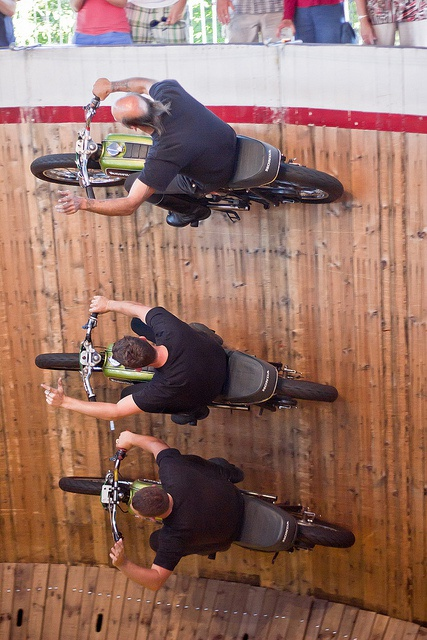Describe the objects in this image and their specific colors. I can see people in lightpink, black, and purple tones, people in lightpink, black, brown, and gray tones, people in lightpink, black, maroon, and brown tones, motorcycle in lightpink, black, gray, and darkgray tones, and motorcycle in lightpink, black, maroon, and gray tones in this image. 